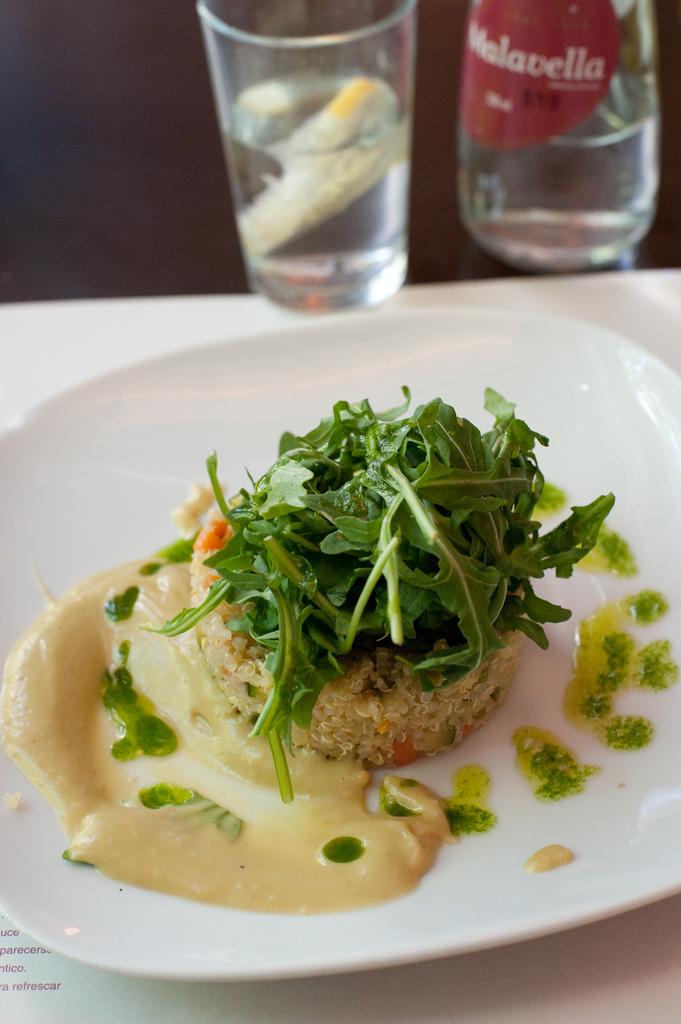What brand is the back right glass?
Provide a succinct answer. Malavella. 